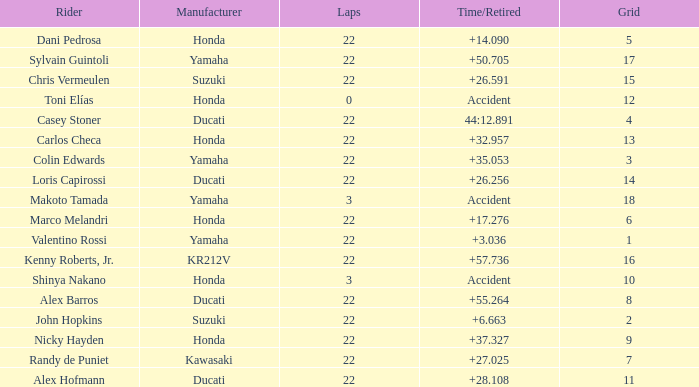What is the average grid for the competitiors who had laps smaller than 3? 12.0. 